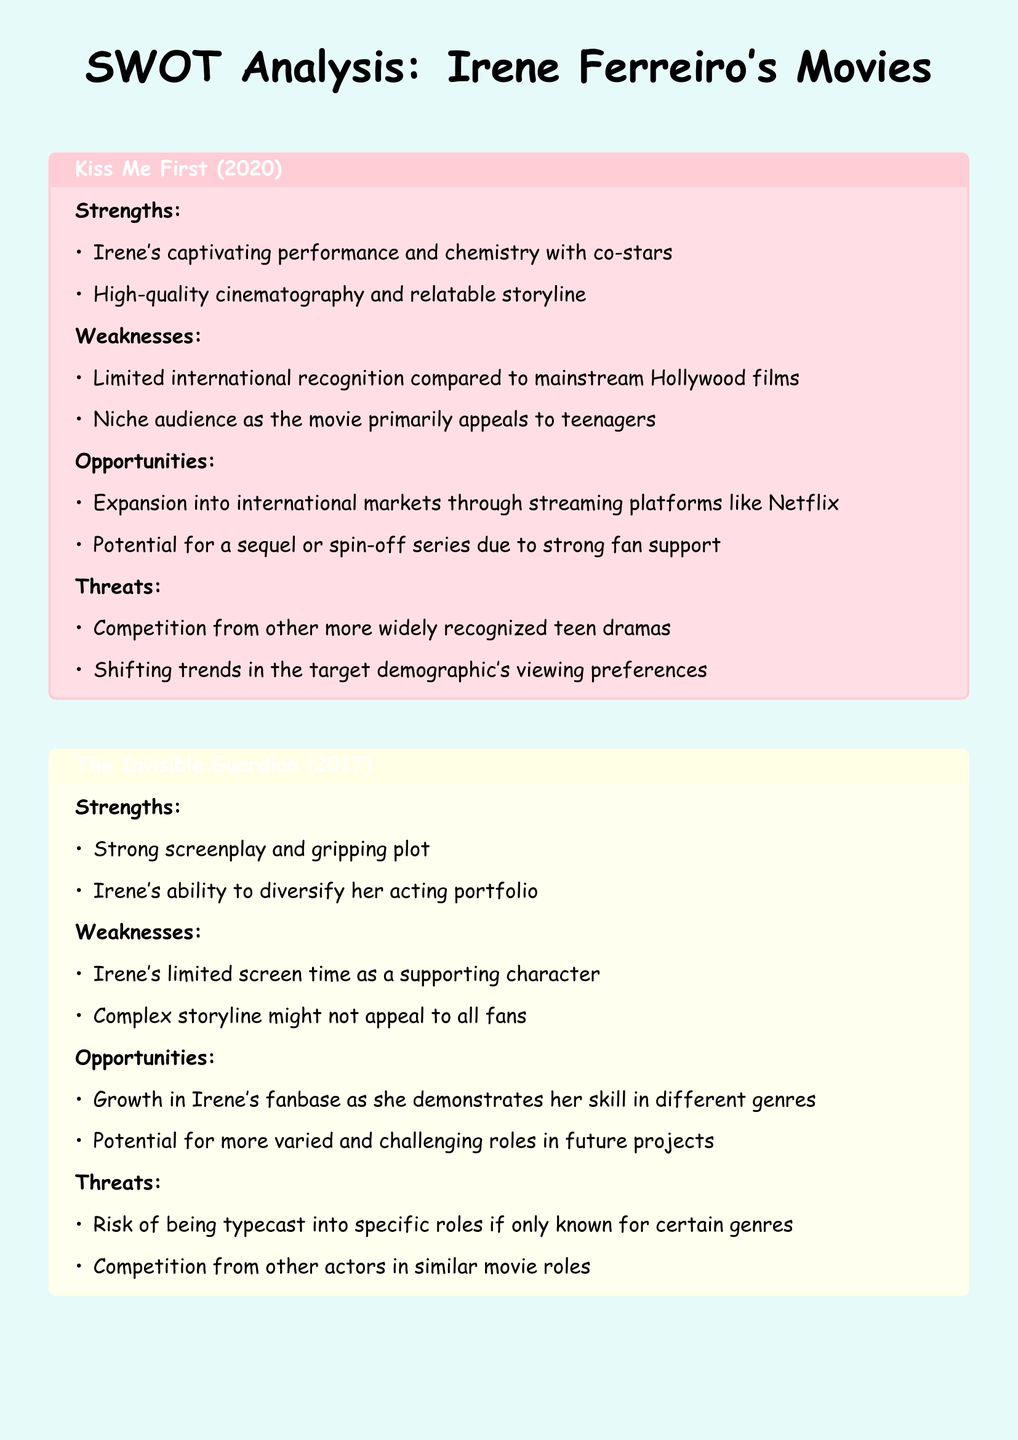What is the title of the first movie analyzed? The title of the first movie analyzed is "Kiss Me First (2020)."
Answer: Kiss Me First (2020) What is one strength of "The Invisible Guardian (2017)"? One strength of "The Invisible Guardian (2017)" is its strong screenplay and gripping plot.
Answer: Strong screenplay and gripping plot What opportunity is identified for "Kiss Me First (2020)"? An identified opportunity for "Kiss Me First (2020)" is expansion into international markets through streaming platforms like Netflix.
Answer: Expansion into international markets How many strengths are listed for "80 egunean (2010)"? There are two strengths listed for "80 egunean (2010)."
Answer: Two What is a weakness of "The Invisible Guardian (2017)"? A weakness of "The Invisible Guardian (2017)" is Irene's limited screen time as a supporting character.
Answer: Limited screen time as a supporting character What type of film is "80 egunean (2010)" classified as? "80 egunean (2010)" is classified as an indie and regional film.
Answer: Indie and regional film What threat does "Kiss Me First (2020)" face? A threat that "Kiss Me First (2020)" faces is competition from other more widely recognized teen dramas.
Answer: Competition from other teen dramas Name one opportunity for Irene Ferreiro's career growth mentioned in the document. One opportunity for Irene's career growth mentioned is the potential for more varied and challenging roles in future projects.
Answer: More varied and challenging roles What performance aspect is highlighted for Irene in "80 egunean (2010)"? Irene's early yet impactful performance is highlighted in "80 egunean (2010)."
Answer: Early yet impactful performance 